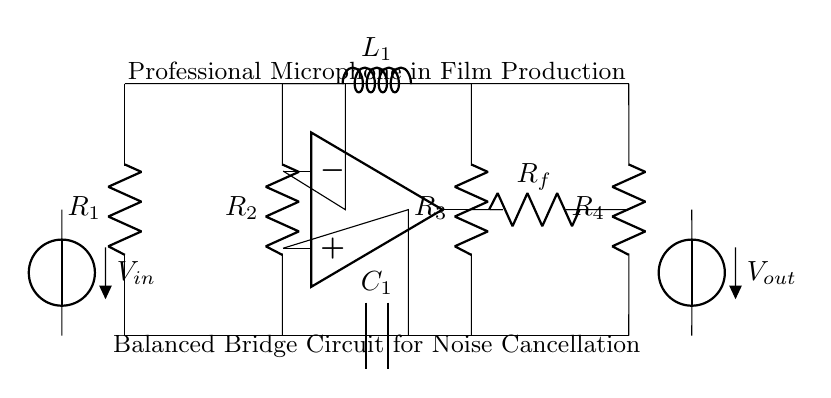What are the resistors in the circuit? The resistors present in the circuit diagram are R1, R2, R3, and R4. These components are labeled clearly on the circuit, indicating their positions in the balanced bridge configuration.
Answer: R1, R2, R3, R4 What is the role of the inductor in this circuit? The inductor labeled L1 is connected in the upper part of the bridge, and its role is likely to help create a balanced scenario for noise cancellation by managing the reactive elements in the signal path.
Answer: Noise cancellation How many capacitors are present in the circuit? There is one capacitor in the circuit identified as C1, which is positioned in the lower part of the balanced bridge. Its presence contributes to the frequency response of the circuit.
Answer: One What type of circuit is illustrated here? The circuit is a balanced bridge circuit designed specifically for audio applications, highlighting its use in professional microphones for noise cancellation. The configuration illustrates a bridge setup for differential signal processing.
Answer: Balanced bridge circuit What is the purpose of the operational amplifier in this circuit? The operational amplifier (shown at node op amp) functions as a differential amplifier, which is crucial for amplifying the difference between two input signals while minimizing common-mode noise, therefore aiding in the noise cancellation process.
Answer: Differential amplification 